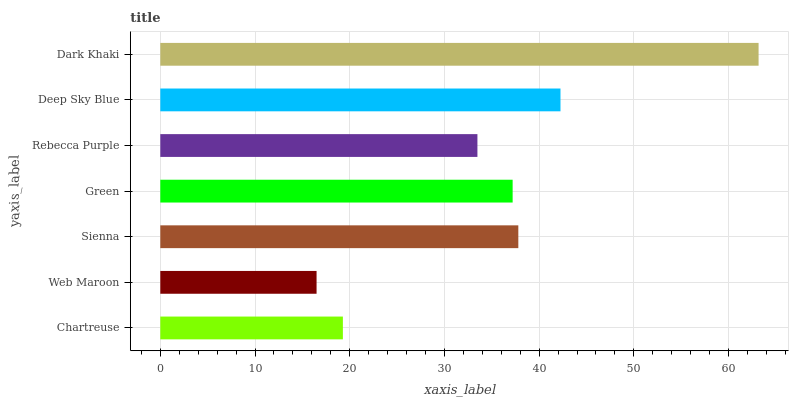Is Web Maroon the minimum?
Answer yes or no. Yes. Is Dark Khaki the maximum?
Answer yes or no. Yes. Is Sienna the minimum?
Answer yes or no. No. Is Sienna the maximum?
Answer yes or no. No. Is Sienna greater than Web Maroon?
Answer yes or no. Yes. Is Web Maroon less than Sienna?
Answer yes or no. Yes. Is Web Maroon greater than Sienna?
Answer yes or no. No. Is Sienna less than Web Maroon?
Answer yes or no. No. Is Green the high median?
Answer yes or no. Yes. Is Green the low median?
Answer yes or no. Yes. Is Rebecca Purple the high median?
Answer yes or no. No. Is Web Maroon the low median?
Answer yes or no. No. 